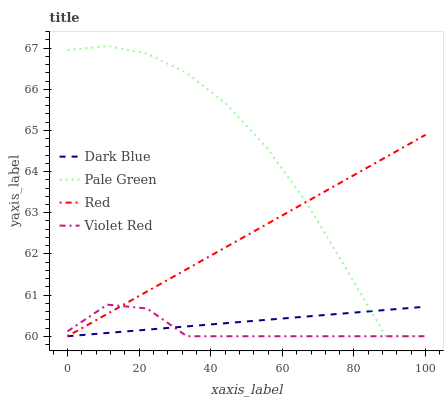Does Violet Red have the minimum area under the curve?
Answer yes or no. Yes. Does Pale Green have the maximum area under the curve?
Answer yes or no. Yes. Does Pale Green have the minimum area under the curve?
Answer yes or no. No. Does Violet Red have the maximum area under the curve?
Answer yes or no. No. Is Dark Blue the smoothest?
Answer yes or no. Yes. Is Pale Green the roughest?
Answer yes or no. Yes. Is Violet Red the smoothest?
Answer yes or no. No. Is Violet Red the roughest?
Answer yes or no. No. Does Dark Blue have the lowest value?
Answer yes or no. Yes. Does Pale Green have the highest value?
Answer yes or no. Yes. Does Violet Red have the highest value?
Answer yes or no. No. Does Pale Green intersect Violet Red?
Answer yes or no. Yes. Is Pale Green less than Violet Red?
Answer yes or no. No. Is Pale Green greater than Violet Red?
Answer yes or no. No. 